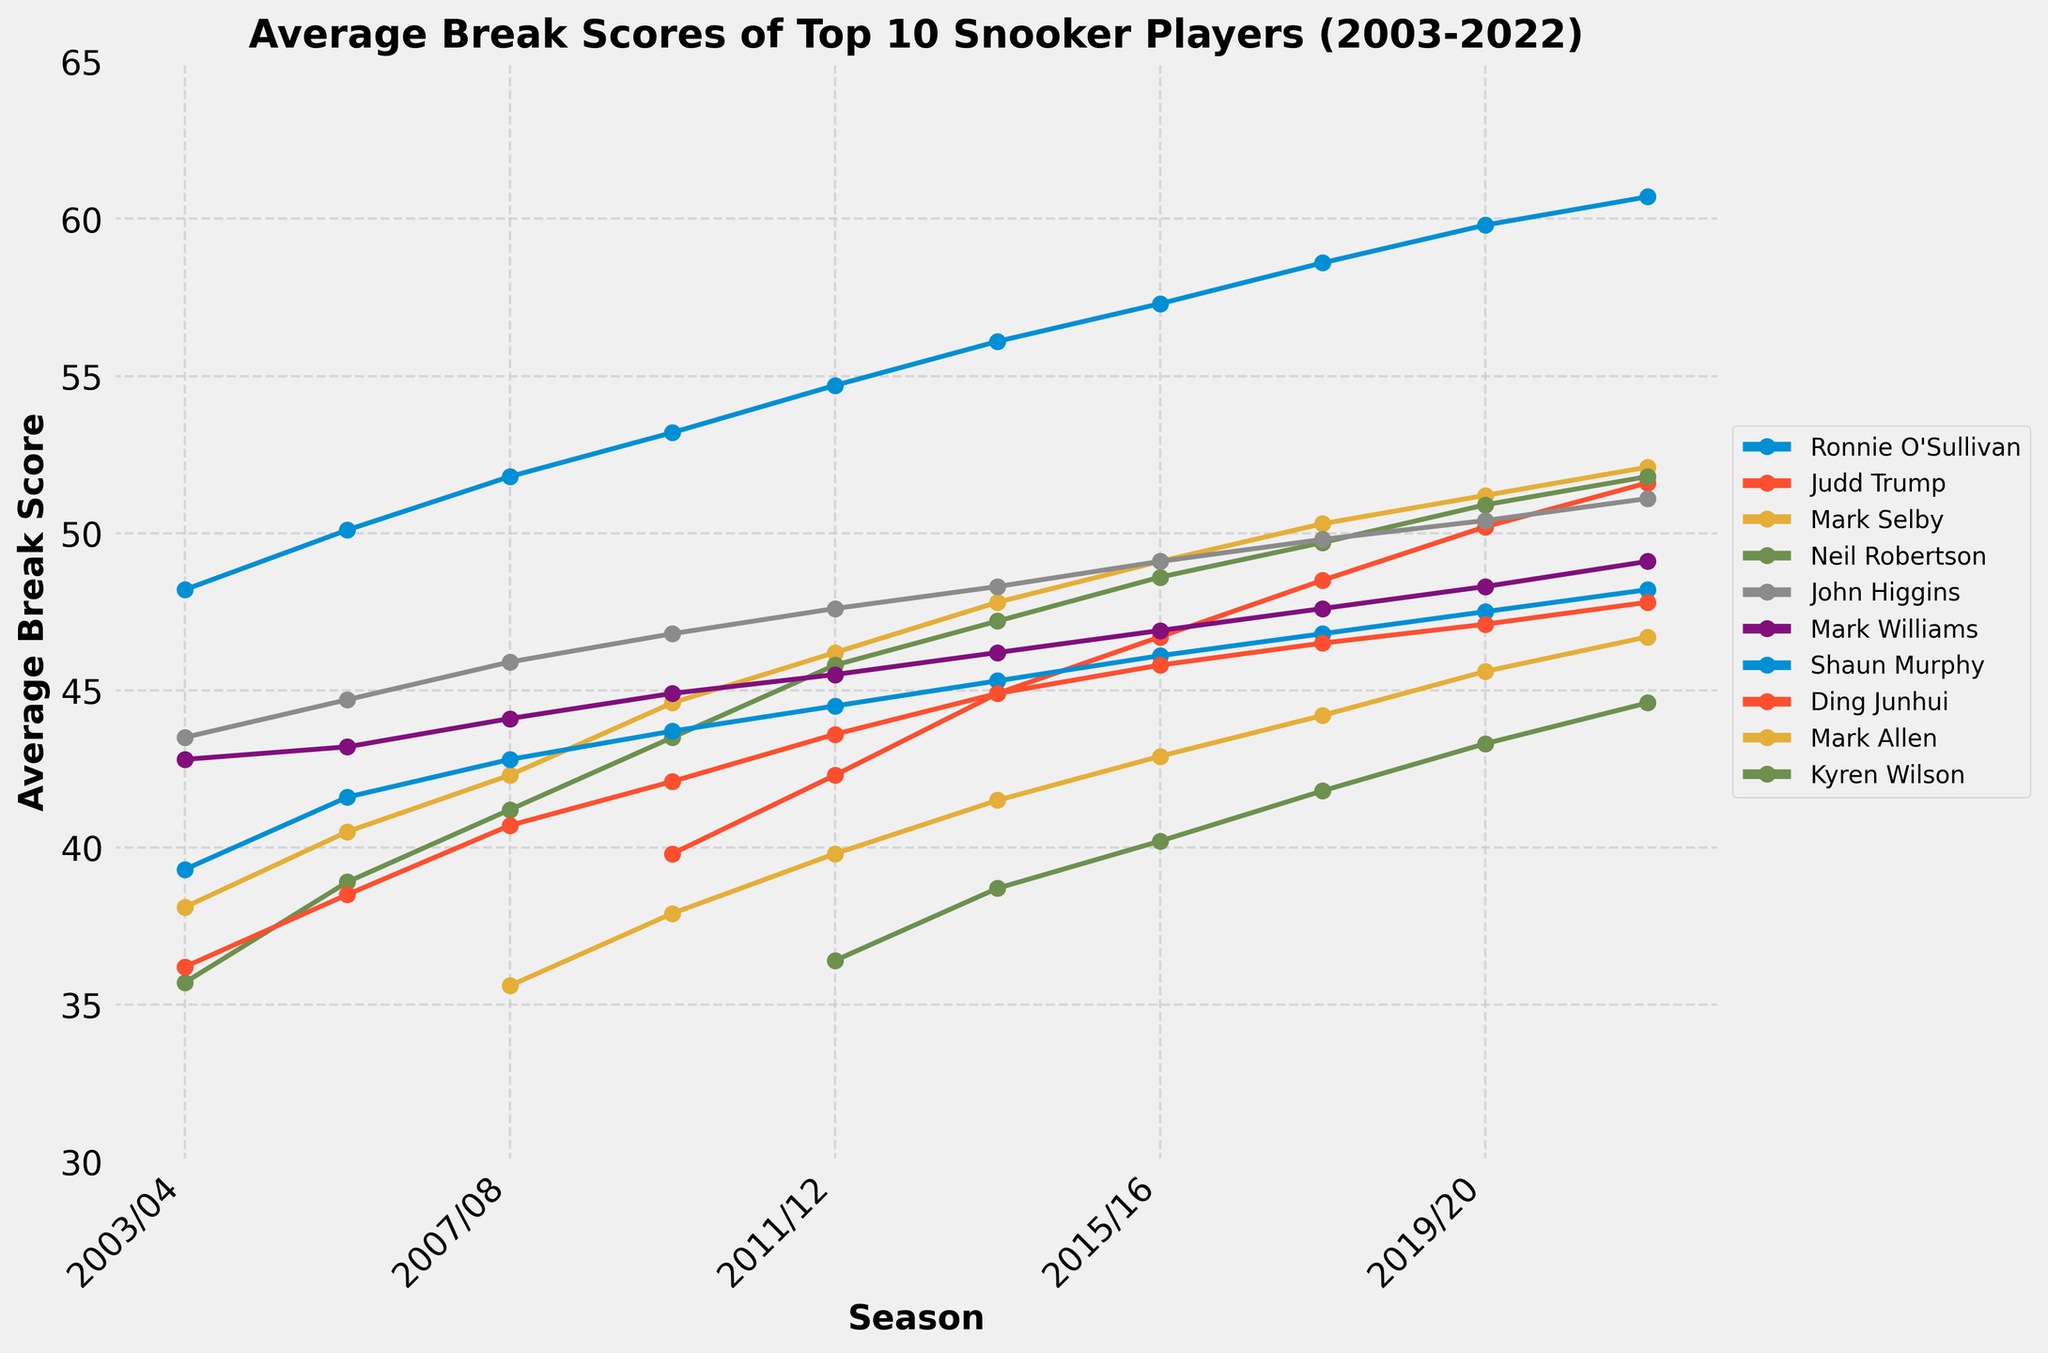What is the difference between Ronnie O'Sullivan's average break score in the 2003/04 season and the 2021/22 season? To find the difference, refer to the average break scores of Ronnie O'Sullivan in the 2003/04 season and the 2021/22 season. Subtract the value of the 2003/04 season (48.2) from the value of the 2021/22 season (60.7). 60.7 - 48.2 = 12.5
Answer: 12.5 Which player had the highest average break score in the 2019/20 season? Check the average break score for each player in the 2019/20 season from the line chart. Identify the highest value among these scores. Ronnie O'Sullivan has the highest score of 59.8.
Answer: Ronnie O'Sullivan How did Neil Robertson's average break score change from the 2003/04 season to the 2021/22 season? Look at Neil Robertson's break scores for both seasons, 2003/04 (35.7) and 2021/22 (51.8). Then subtract the earlier season's score from the later season's score to find the change. 51.8 - 35.7 = 16.1
Answer: Increased by 16.1 Compare the average break scores of Judd Trump and Mark Selby in the 2015/16 season. Find Judd Trump’s and Mark Selby's scores from the chart in the 2015/16 season. Judd Trump has a score of 46.7 and Mark Selby has a score of 49.1. Compare the two values: 46.7 < 49.1
Answer: Mark Selby had a higher score What is the average break score of John Higgins over the 10 seasons shown? Add up John Higgins' average break scores for all ten seasons and then divide by 10 to calculate the average: (43.5 + 44.7 + 45.9 + 46.8 + 47.6 + 48.3 + 49.1 + 49.8 + 50.4 + 51.1) / 10 = 47.72.
Answer: 47.72 Did Mark Williams' average break score increase or decrease from the 2017/18 season to the 2019/20 season? Refer to Mark Williams' scores for the 2017/18 (47.6) and 2019/20 (48.3) seasons, and compare them. 48.3 > 47.6, so the score increased.
Answer: Increased What visual change can be observed in Mark Allen's average break scores from the 2009/10 season to the 2021/22 season? Look at the plotted line for Mark Allen from 2009/10 to 2021/22. The line proceeds upwards, showing a general increasing trend in his average break scores over the seasons.
Answer: Increasing trend Who had a higher average break score in the 2013/14 season, Ding Junhui or Shaun Murphy? Check Ding Junhui's (44.9) and Shaun Murphy's (45.3) scores for the 2013/14 season from the line chart. Comparing the two, 45.3 > 44.9.
Answer: Shaun Murphy Which player shows a consistent increase in their average break score over all seasons? Examine the plotted lines for all players. Ronnie O'Sullivan's line steadily increases each season without any drops, indicating a consistent increase.
Answer: Ronnie O'Sullivan 